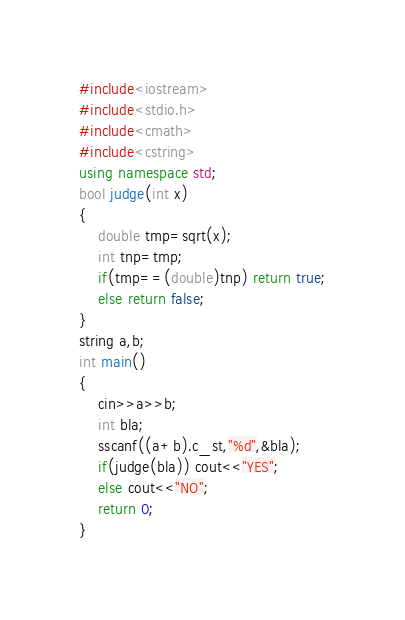<code> <loc_0><loc_0><loc_500><loc_500><_C++_>#include<iostream>
#include<stdio.h>
#include<cmath>
#include<cstring>
using namespace std;
bool judge(int x)
{
    double tmp=sqrt(x);
    int tnp=tmp;
    if(tmp==(double)tnp) return true;
    else return false;
}
string a,b;
int main()
{
    cin>>a>>b;
    int bla;
    sscanf((a+b).c_st,"%d",&bla);
    if(judge(bla)) cout<<"YES";
    else cout<<"NO";
    return 0;
}</code> 